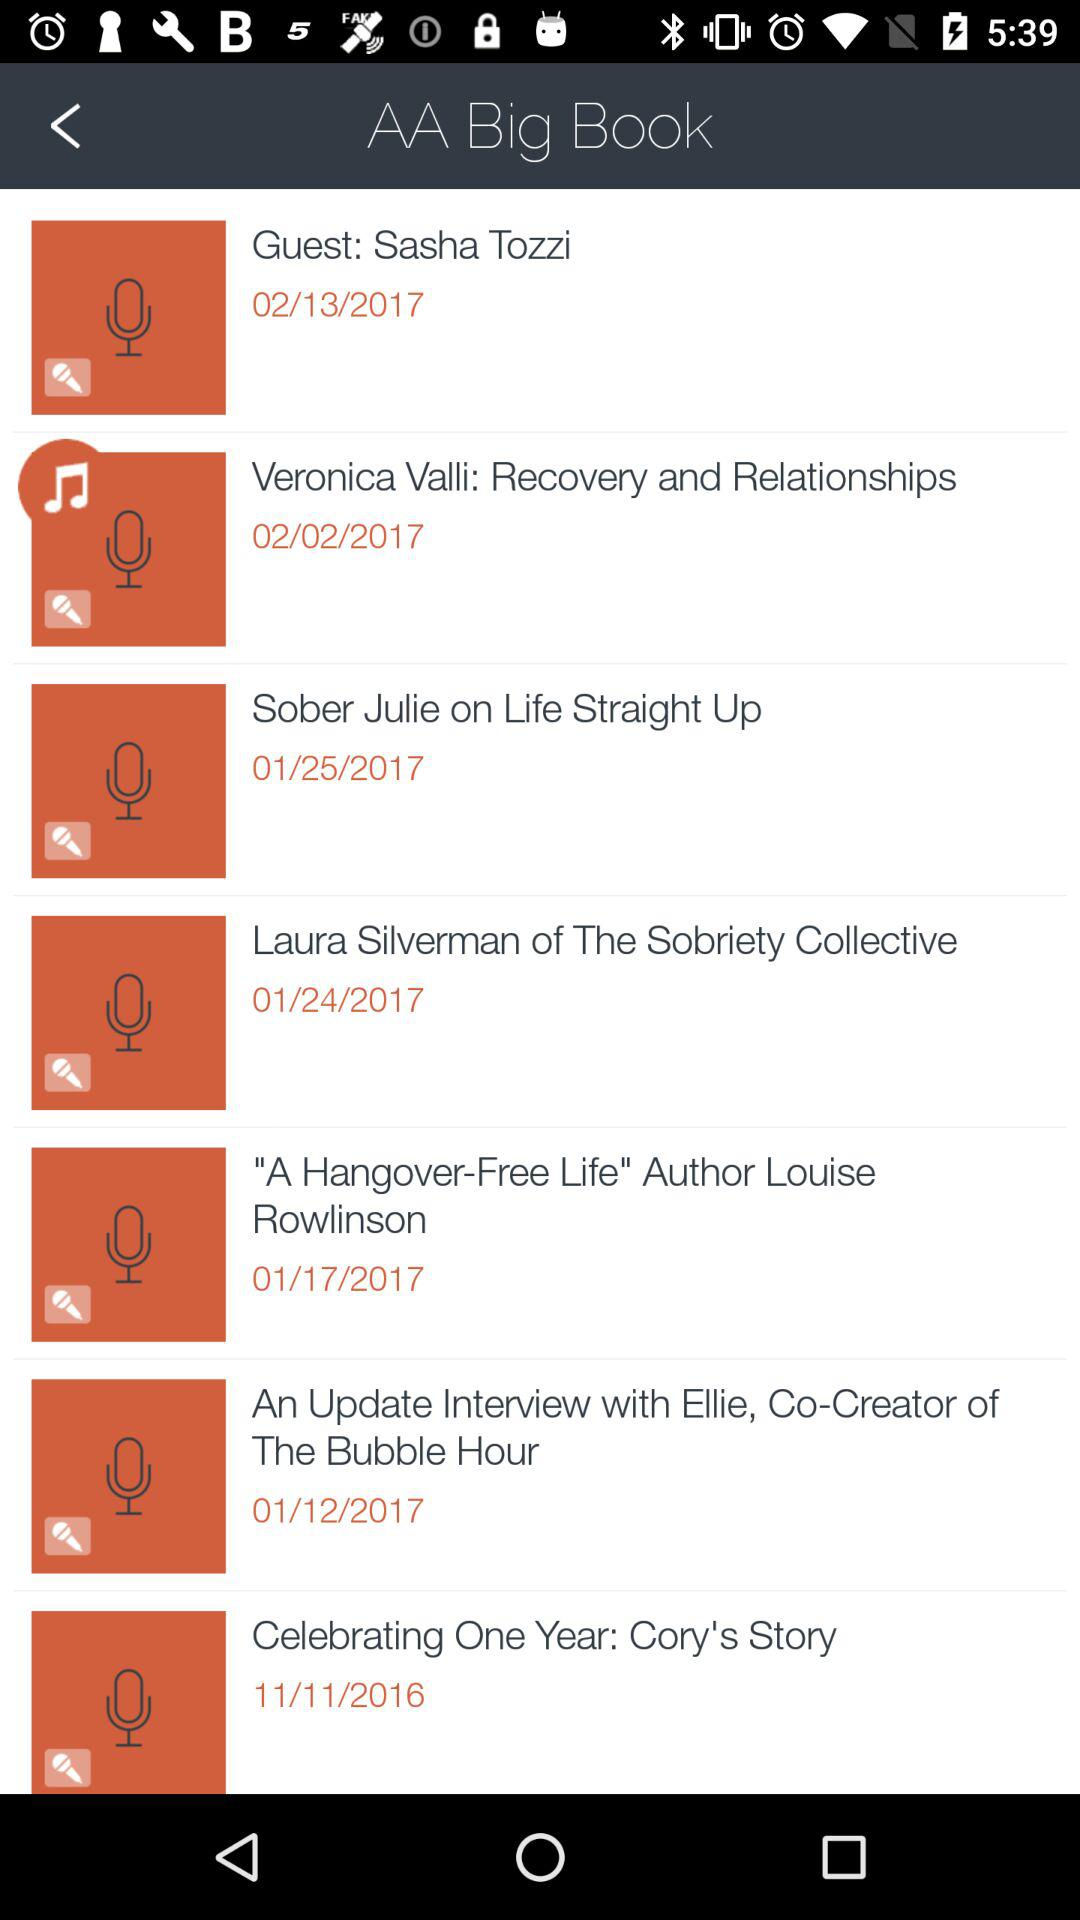What is the date of "Guest: Sasha Tozzi"? The date is 02/13/2017. 